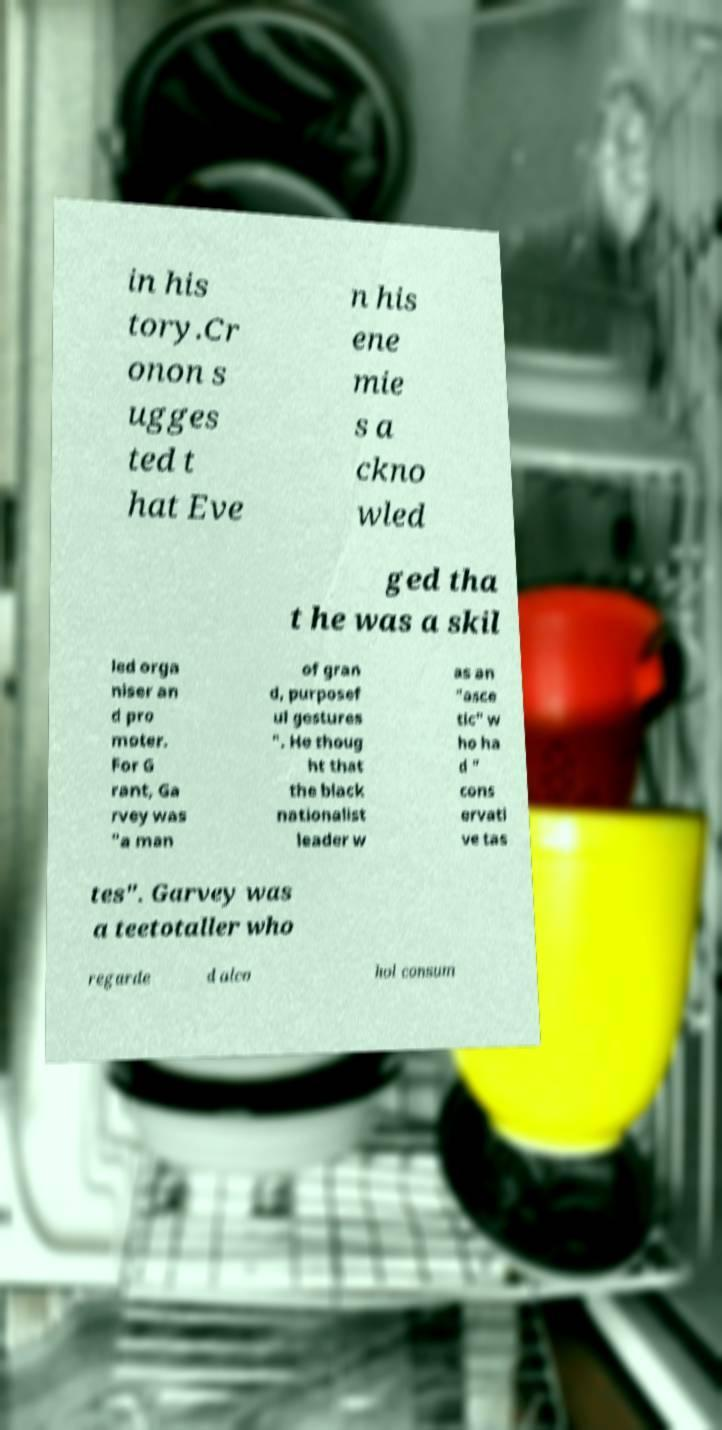There's text embedded in this image that I need extracted. Can you transcribe it verbatim? in his tory.Cr onon s ugges ted t hat Eve n his ene mie s a ckno wled ged tha t he was a skil led orga niser an d pro moter. For G rant, Ga rvey was "a man of gran d, purposef ul gestures ". He thoug ht that the black nationalist leader w as an "asce tic" w ho ha d " cons ervati ve tas tes". Garvey was a teetotaller who regarde d alco hol consum 